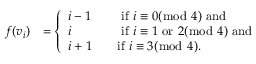<formula> <loc_0><loc_0><loc_500><loc_500>\begin{array} { r l } { f ( v _ { i } ) } & { = \left \{ \begin{array} { l l } { i - 1 \quad } & { i f i \equiv 0 ( \bmod 4 ) a n d } \\ { i \quad } & { i f i \equiv 1 o r 2 ( \bmod 4 ) a n d } \\ { i + 1 \quad } & { i f i \equiv 3 ( \bmod 4 ) . } \end{array} } \end{array}</formula> 